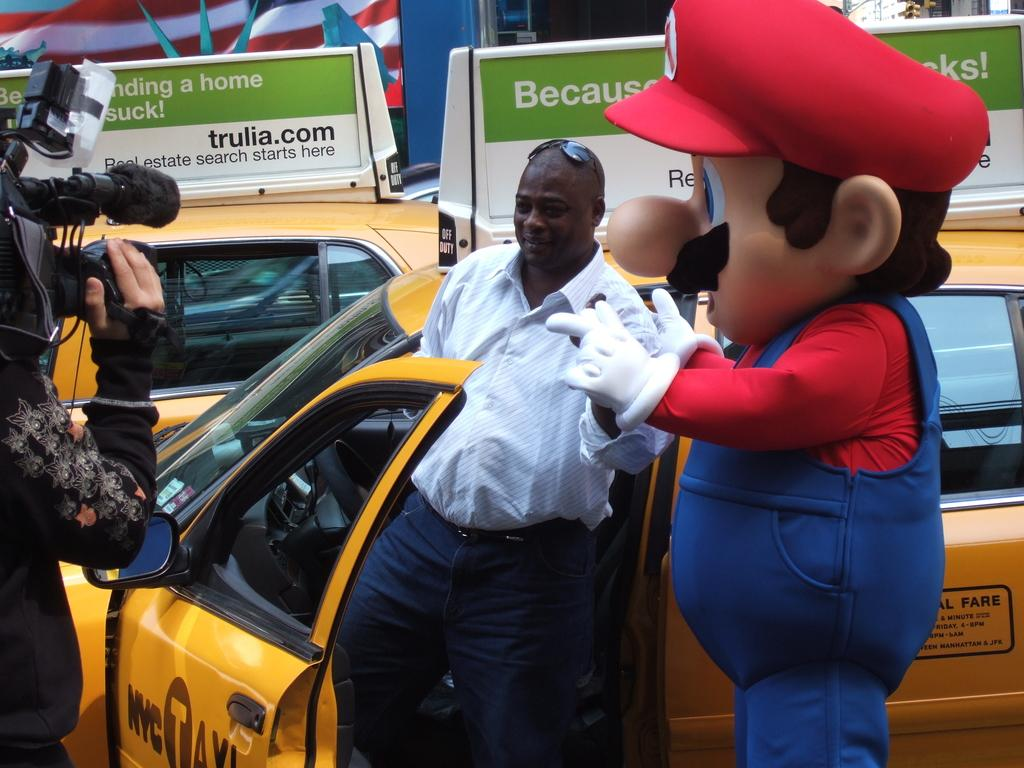<image>
Provide a brief description of the given image. A Mario mascot stands outside of a New York City taxi. 